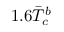Convert formula to latex. <formula><loc_0><loc_0><loc_500><loc_500>1 . 6 \ B a r { T } _ { c } ^ { b }</formula> 